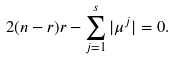Convert formula to latex. <formula><loc_0><loc_0><loc_500><loc_500>2 ( n - r ) r - \sum _ { j = 1 } ^ { s } | \mu ^ { j } | = 0 .</formula> 